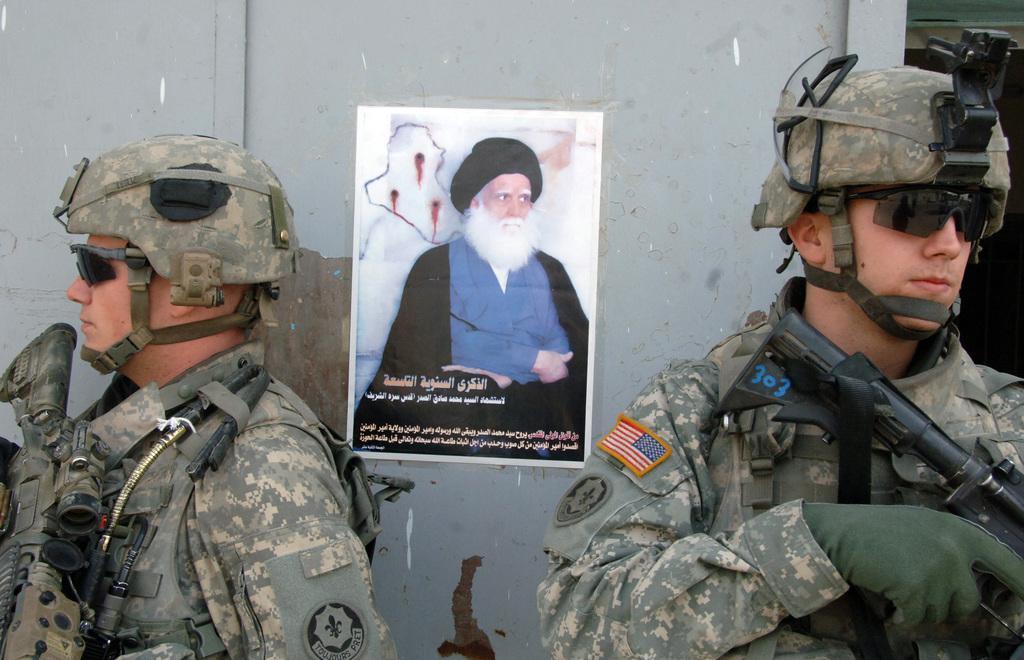How would you summarize this image in a sentence or two? In this picture there are two men towards the left and right. Both of them are wearing uniforms,helmets, spectacles and holding guns. In the middle of them, there is a wall. On the wall, there is a poster of a man. He is wearing a blue dress. On the poster there is some text. 